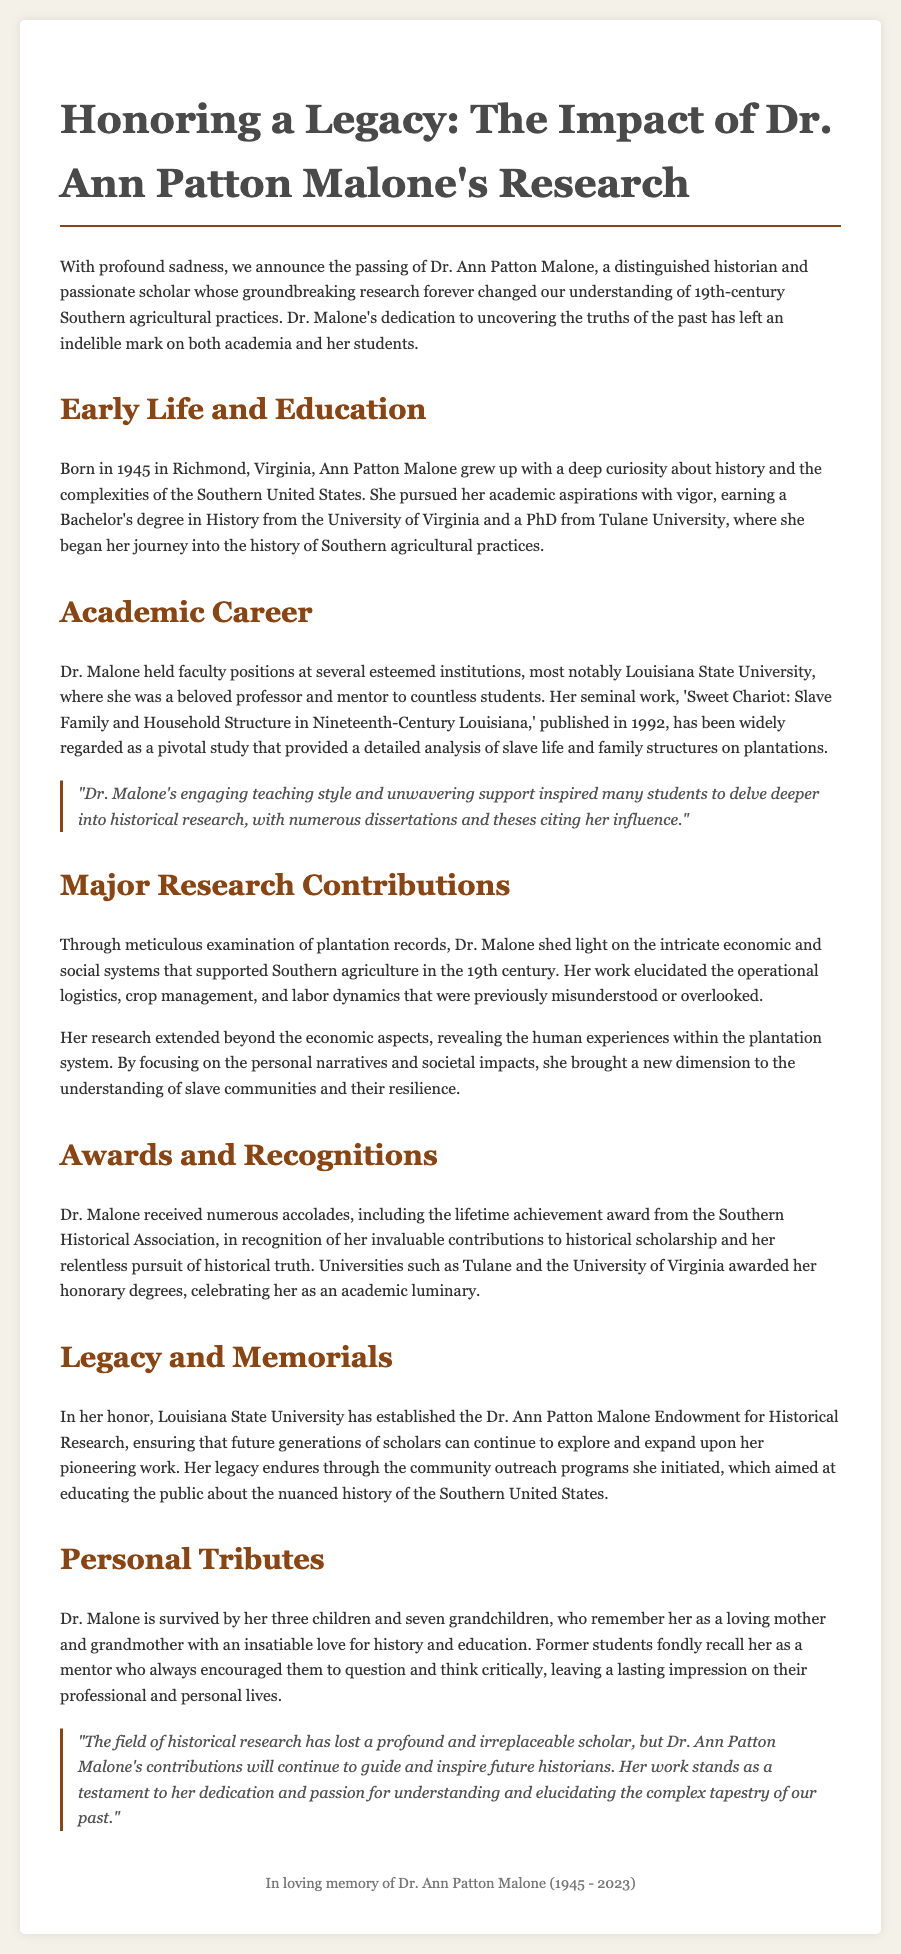What year was Dr. Ann Patton Malone born? The document states the year of Dr. Malone's birth as 1945.
Answer: 1945 What university did Dr. Malone receive her Bachelor's degree from? According to the document, Dr. Malone earned her Bachelor's degree in History from the University of Virginia.
Answer: University of Virginia Which book is considered Dr. Malone's seminal work? The document mentions her book titled 'Sweet Chariot: Slave Family and Household Structure in Nineteenth-Century Louisiana' as her seminal work.
Answer: 'Sweet Chariot: Slave Family and Household Structure in Nineteenth-Century Louisiana' What major award did Dr. Malone receive? The document specifies that she received a lifetime achievement award from the Southern Historical Association.
Answer: lifetime achievement award What is the name of the endowment established in Dr. Malone's honor? The document states that the endowment established is called the Dr. Ann Patton Malone Endowment for Historical Research.
Answer: Dr. Ann Patton Malone Endowment for Historical Research Why is Dr. Malone considered a significant scholar? The document refers to her groundbreaking research that changed the understanding of 19th-century Southern agricultural practices as the reason for her significance.
Answer: groundbreaking research What role did Dr. Malone have at Louisiana State University? The document indicates that Dr. Malone held a faculty position at Louisiana State University as a beloved professor.
Answer: beloved professor How many grandchildren did Dr. Malone have? The document mentions that Dr. Malone is survived by seven grandchildren.
Answer: seven grandchildren 